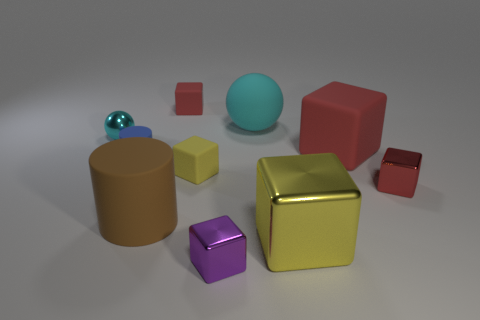How many red blocks must be subtracted to get 1 red blocks? 2 Subtract all yellow cylinders. How many red blocks are left? 3 Subtract all yellow cubes. How many cubes are left? 4 Subtract all purple cubes. How many cubes are left? 5 Subtract all cyan blocks. Subtract all brown cylinders. How many blocks are left? 6 Subtract all blocks. How many objects are left? 4 Add 10 small red metallic spheres. How many small red metallic spheres exist? 10 Subtract 0 gray cubes. How many objects are left? 10 Subtract all cyan objects. Subtract all yellow shiny things. How many objects are left? 7 Add 2 small blocks. How many small blocks are left? 6 